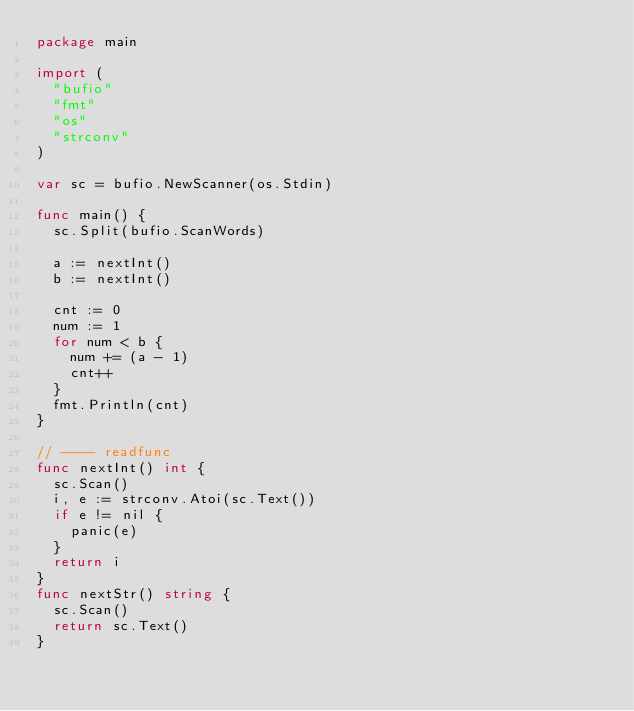<code> <loc_0><loc_0><loc_500><loc_500><_Go_>package main

import (
	"bufio"
	"fmt"
	"os"
	"strconv"
)

var sc = bufio.NewScanner(os.Stdin)

func main() {
	sc.Split(bufio.ScanWords)

	a := nextInt()
	b := nextInt()

	cnt := 0
	num := 1
	for num < b {
		num += (a - 1)
		cnt++
	}
	fmt.Println(cnt)
}

// ---- readfunc
func nextInt() int {
	sc.Scan()
	i, e := strconv.Atoi(sc.Text())
	if e != nil {
		panic(e)
	}
	return i
}
func nextStr() string {
	sc.Scan()
	return sc.Text()
}
</code> 